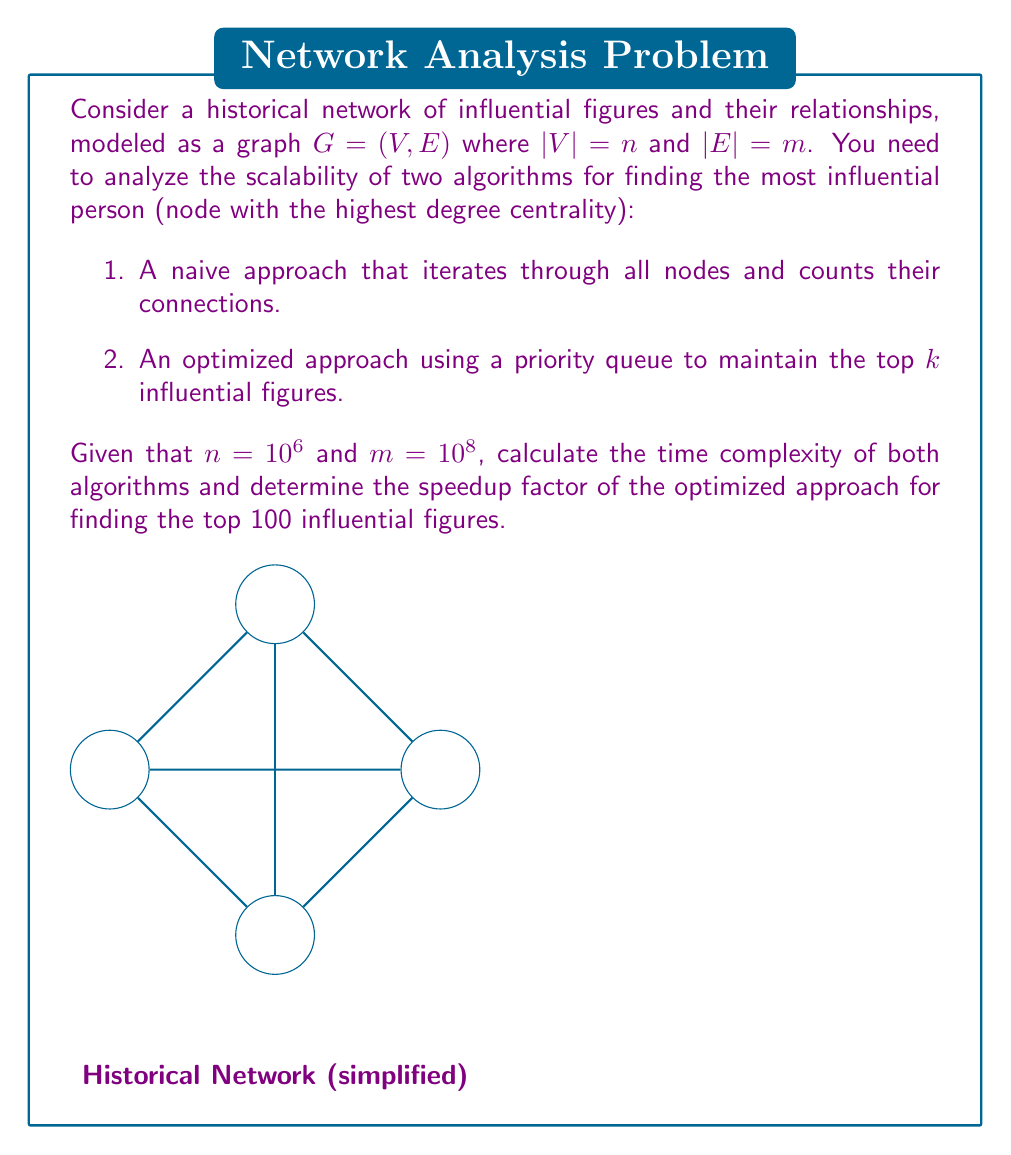Solve this math problem. Let's analyze the time complexity and scalability of both algorithms:

1. Naive Approach:
   - Iterate through all nodes: $O(n)$
   - For each node, count its connections: $O(m)$
   - Total time complexity: $O(n + m)$

2. Optimized Approach (using a priority queue):
   - Build a max heap of size $k$: $O(k)$
   - Iterate through all nodes: $O(n)$
   - For each node, calculate its degree: $O(m)$
   - Update the priority queue: $O(n \log k)$
   - Total time complexity: $O(k + n \log k + m)$

Given $n=10^6$, $m=10^8$, and $k=100$:

Naive Approach:
$T_{naive} = O(n + m) = O(10^6 + 10^8) \approx O(10^8)$

Optimized Approach:
$T_{optimized} = O(k + n \log k + m) = O(100 + 10^6 \log 100 + 10^8) \approx O(10^8)$

To calculate the speedup factor, we need to consider the constant factors hidden by the big O notation. The optimized approach reduces the number of priority queue operations from $n$ to $\log k$ for each node, which is a significant improvement.

Approximate speedup factor:
$$\text{Speedup} \approx \frac{n}{n \log k} = \frac{10^6}{10^6 \log 100} \approx \frac{10^6}{10^6 \cdot 6.64} \approx 0.15$$

This means the optimized approach is approximately 6.67 times faster than the naive approach for finding the top 100 influential figures in this large historical network.
Answer: 6.67x speedup 